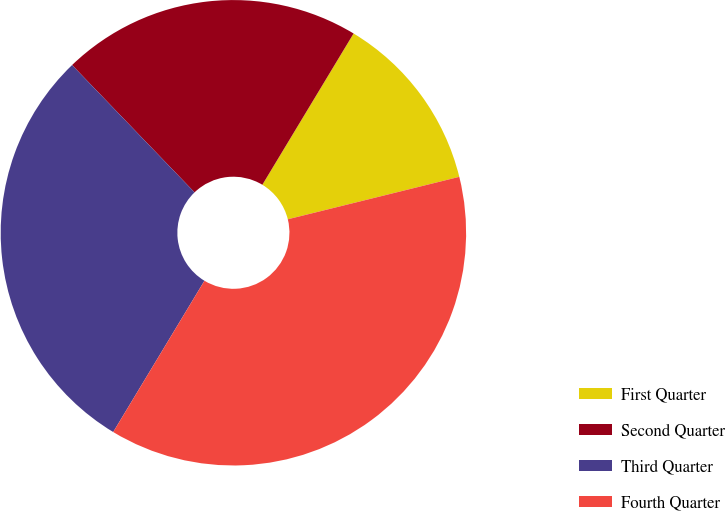Convert chart to OTSL. <chart><loc_0><loc_0><loc_500><loc_500><pie_chart><fcel>First Quarter<fcel>Second Quarter<fcel>Third Quarter<fcel>Fourth Quarter<nl><fcel>12.5%<fcel>20.83%<fcel>29.17%<fcel>37.5%<nl></chart> 